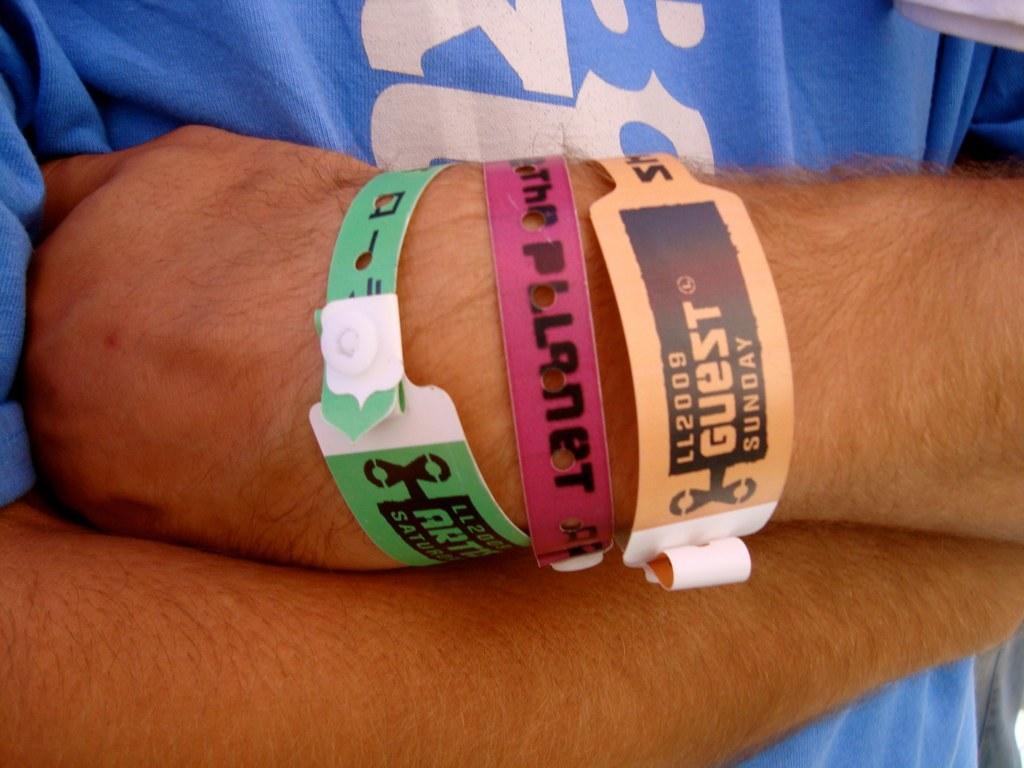Please provide a concise description of this image. In this picture, we see the man in blue T-shirt is standing. In front of the picture, we see the hands of the man who is wearing the hand bands which are in green, pink ad orange color. 